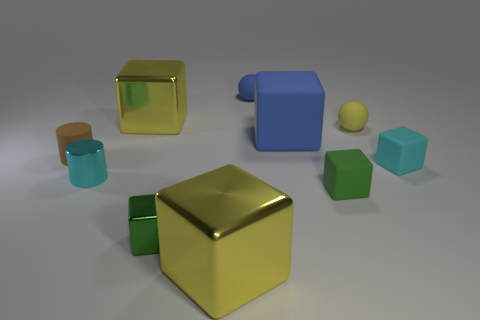Subtract all green cubes. How many were subtracted if there are1green cubes left? 1 Subtract all spheres. How many objects are left? 8 Subtract 4 cubes. How many cubes are left? 2 Subtract all blue cylinders. Subtract all purple balls. How many cylinders are left? 2 Subtract all blue cylinders. How many yellow balls are left? 1 Subtract all big yellow cubes. Subtract all large blue objects. How many objects are left? 7 Add 1 blocks. How many blocks are left? 7 Add 10 small gray metallic things. How many small gray metallic things exist? 10 Subtract all blue blocks. How many blocks are left? 5 Subtract all tiny green matte blocks. How many blocks are left? 5 